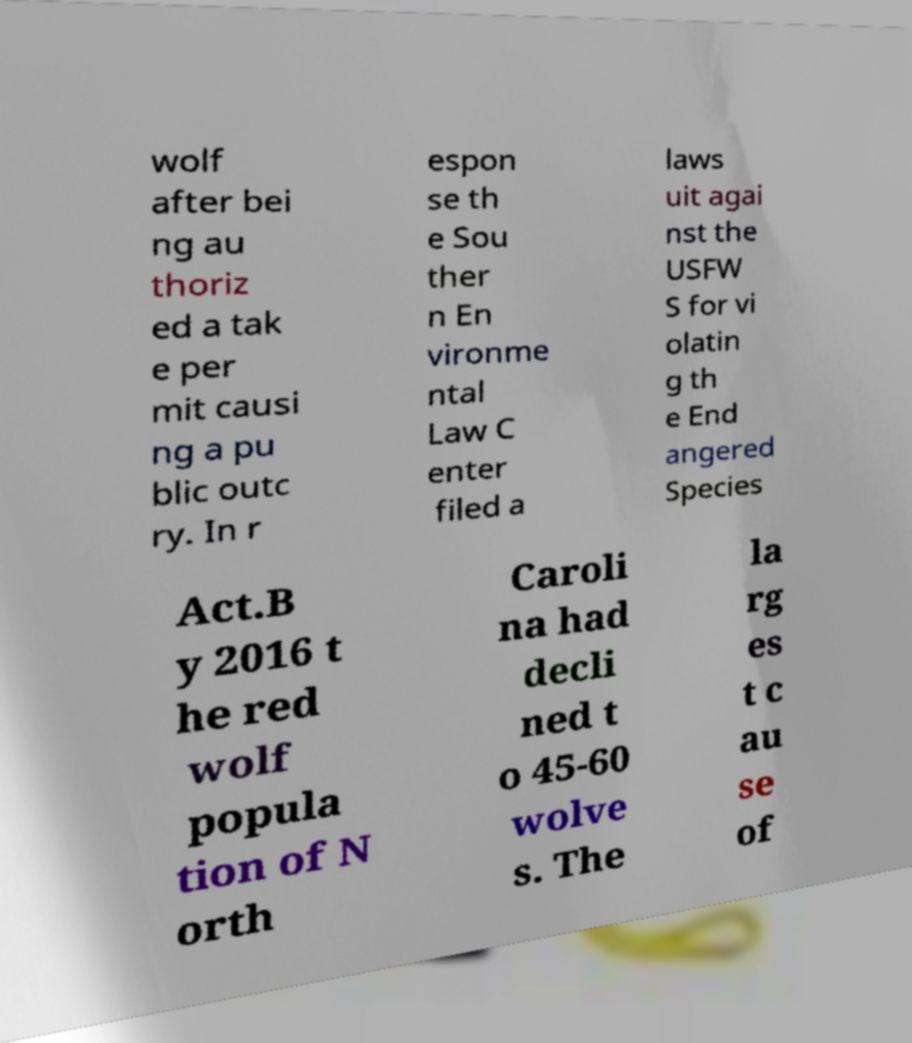For documentation purposes, I need the text within this image transcribed. Could you provide that? wolf after bei ng au thoriz ed a tak e per mit causi ng a pu blic outc ry. In r espon se th e Sou ther n En vironme ntal Law C enter filed a laws uit agai nst the USFW S for vi olatin g th e End angered Species Act.B y 2016 t he red wolf popula tion of N orth Caroli na had decli ned t o 45-60 wolve s. The la rg es t c au se of 